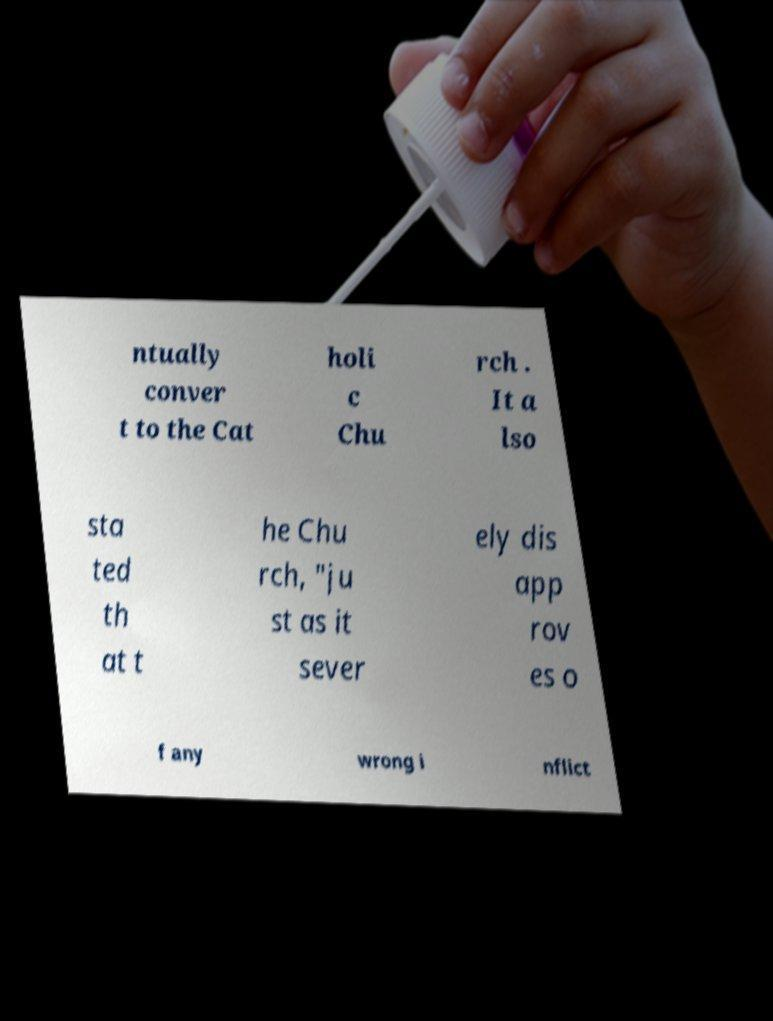Could you assist in decoding the text presented in this image and type it out clearly? ntually conver t to the Cat holi c Chu rch . It a lso sta ted th at t he Chu rch, "ju st as it sever ely dis app rov es o f any wrong i nflict 